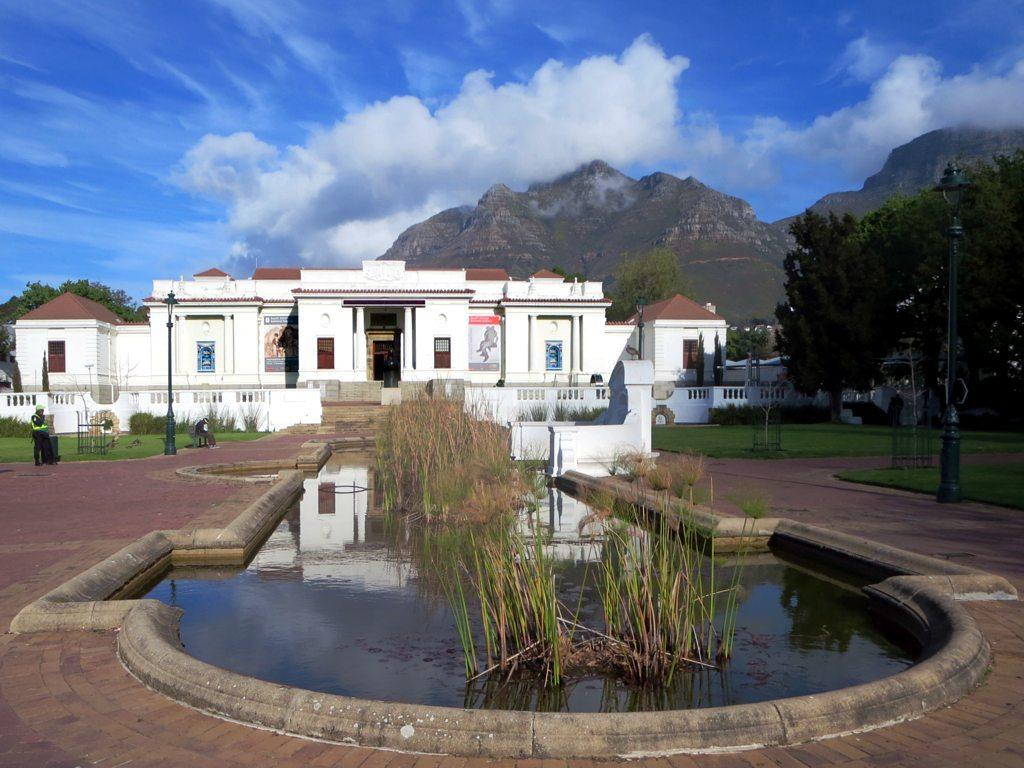What type of structure can be seen in the image? There is a building in the image. What are the vertical structures with signs or lights in the image? There are street poles in the image. What are the tall, illuminated structures in the image? There are street lights in the image. Can you describe the people in the image? There are persons standing in the image. What type of vegetation is present in the image? There is grass in the image. What natural element can be seen in the image? There is water in the image. What type of trees are in the image? There are trees in the image. What type of landscape feature is present in the image? There are hills in the image. What is visible in the top part of the image? The sky is visible in the image. What can be seen in the sky? There are clouds in the sky. How many hands are visible on the persons in the image? The provided facts do not mention the number of hands visible on the persons in the image, nor do they provide any information about hands. What is the range of the street lights in the image? The provided facts do not mention the range of the street lights in the image, nor do they provide any information about the range of the street lights. 